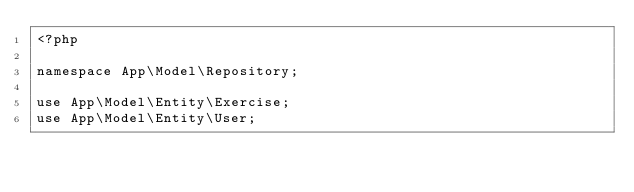<code> <loc_0><loc_0><loc_500><loc_500><_PHP_><?php

namespace App\Model\Repository;

use App\Model\Entity\Exercise;
use App\Model\Entity\User;</code> 